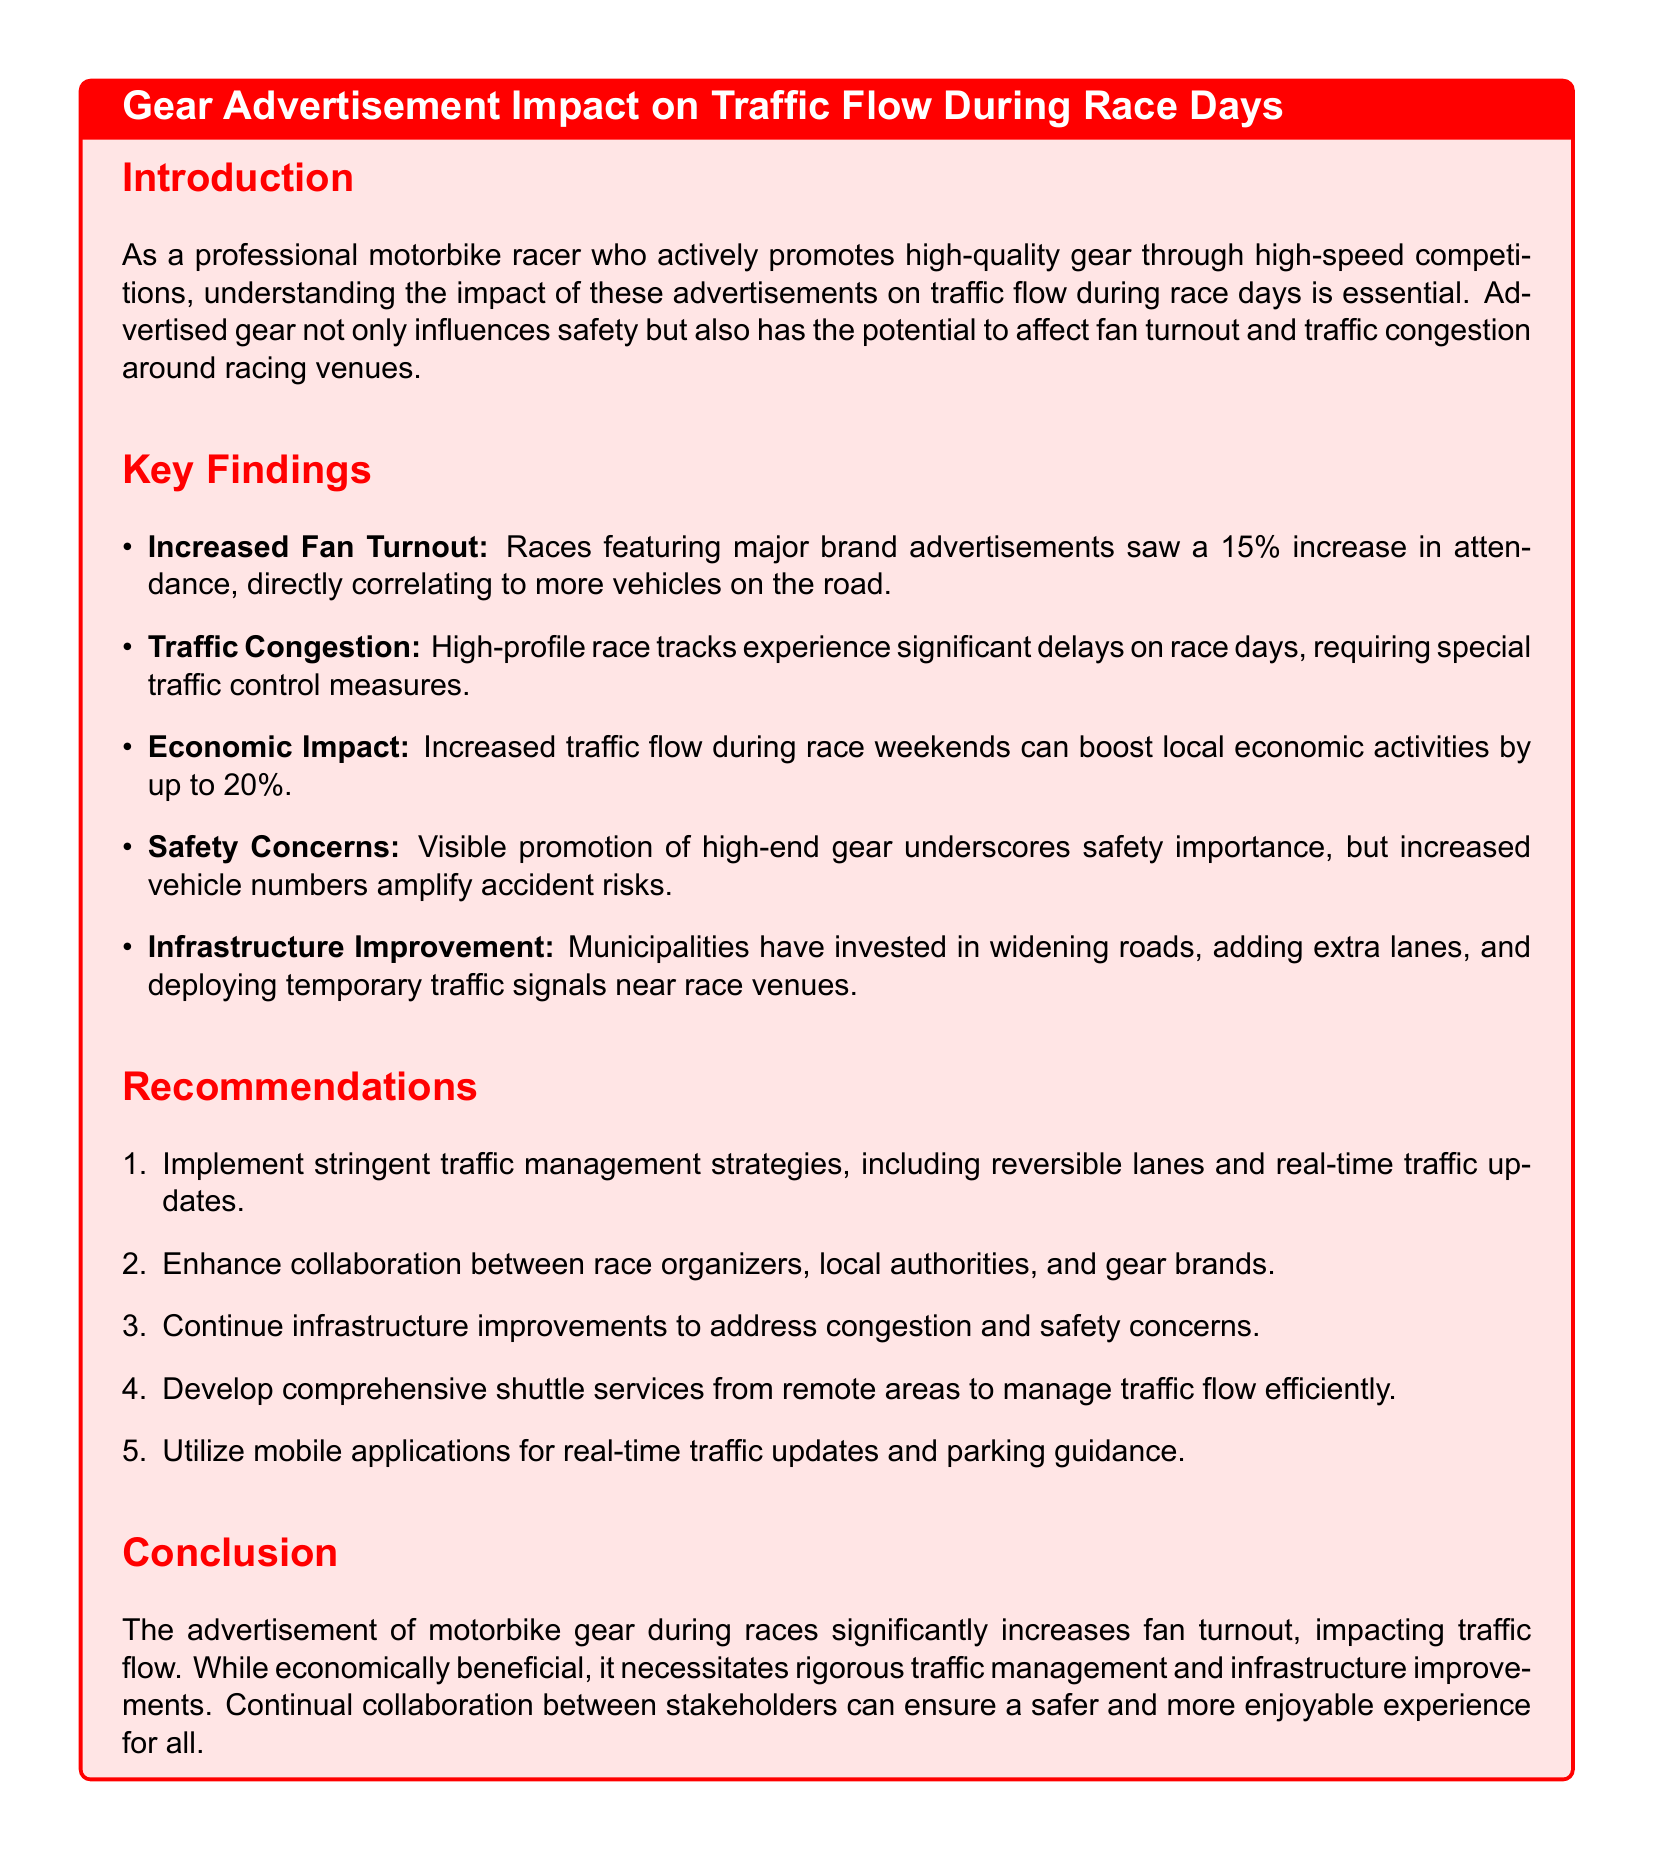What is the percentage increase in attendance for races with major brand advertisements? The report states a 15% increase in attendance for these races.
Answer: 15% What are the notable traffic control measures needed on race days? The key findings highlight significant delays necessitating special traffic control measures.
Answer: Special traffic control measures By what percentage can local economic activities be boosted during race weekends? The document mentions that economic activities can be boosted by up to 20%.
Answer: 20% What is one of the safety concerns mentioned in the report? Increased vehicle numbers amplify accident risks, as highlighted in the safety concerns section.
Answer: Accident risks What recommendation involves collaboration with race organizers? The report suggests enhancing collaboration between race organizers, local authorities, and gear brands.
Answer: Enhance collaboration What infrastructure improvements are municipalities making? The findings indicate investments in widening roads and adding extra lanes near race venues.
Answer: Widening roads What is the primary purpose of the traffic report? The introduction explains that the report aims to understand the impact of gear advertisements on traffic flow during race days.
Answer: Understanding impact What is the impact of gear advertisements on the overall experience? The conclusion states that continual collaboration can ensure a safer and more enjoyable experience for all.
Answer: Safer and more enjoyable experience 